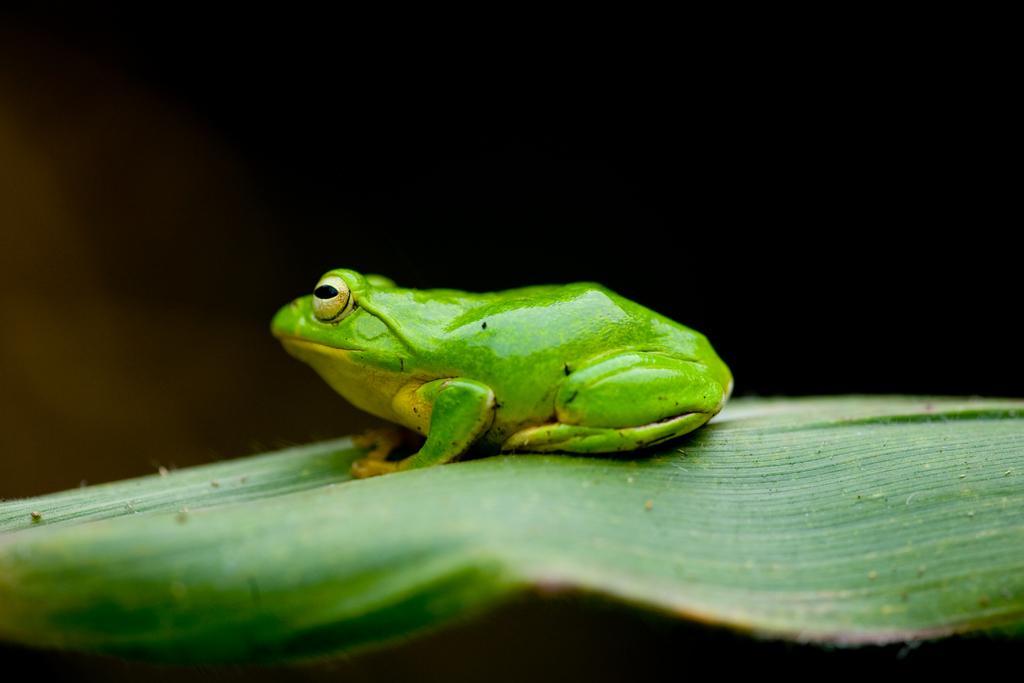In one or two sentences, can you explain what this image depicts? In this image I can see the frog on the leaf and the frog is in green color and I can see the dark background. 